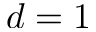Convert formula to latex. <formula><loc_0><loc_0><loc_500><loc_500>d = 1</formula> 